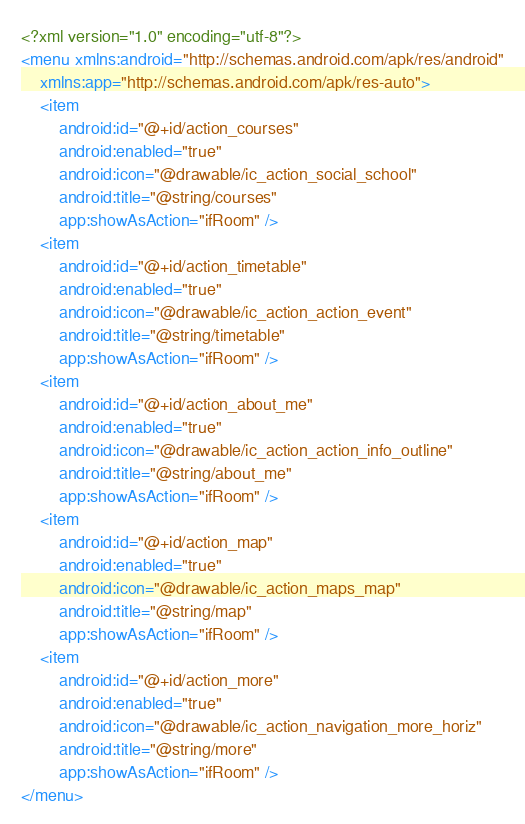Convert code to text. <code><loc_0><loc_0><loc_500><loc_500><_XML_><?xml version="1.0" encoding="utf-8"?>
<menu xmlns:android="http://schemas.android.com/apk/res/android"
    xmlns:app="http://schemas.android.com/apk/res-auto">
    <item
        android:id="@+id/action_courses"
        android:enabled="true"
        android:icon="@drawable/ic_action_social_school"
        android:title="@string/courses"
        app:showAsAction="ifRoom" />
    <item
        android:id="@+id/action_timetable"
        android:enabled="true"
        android:icon="@drawable/ic_action_action_event"
        android:title="@string/timetable"
        app:showAsAction="ifRoom" />
    <item
        android:id="@+id/action_about_me"
        android:enabled="true"
        android:icon="@drawable/ic_action_action_info_outline"
        android:title="@string/about_me"
        app:showAsAction="ifRoom" />
    <item
        android:id="@+id/action_map"
        android:enabled="true"
        android:icon="@drawable/ic_action_maps_map"
        android:title="@string/map"
        app:showAsAction="ifRoom" />
    <item
        android:id="@+id/action_more"
        android:enabled="true"
        android:icon="@drawable/ic_action_navigation_more_horiz"
        android:title="@string/more"
        app:showAsAction="ifRoom" />
</menu></code> 